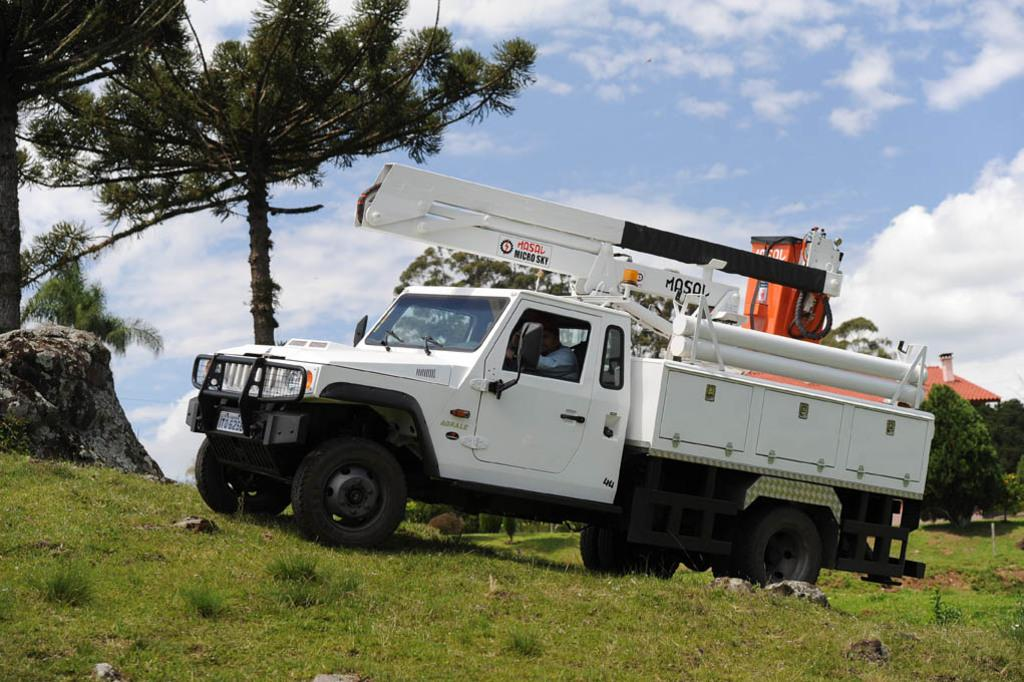What is happening in the image involving a person and a vehicle? There is a person inside a vehicle in the image. Can you describe the setting in which the vehicle is passing? The vehicle is passing on the grass. What other objects or structures can be seen in the image? There is a rock, a house, and trees in the image. What is visible in the background of the image? The sky is visible in the background of the image, and clouds are present in the sky. What is the income of the person driving the vehicle in the image? There is no information about the person's income in the image. How many friends are visible in the image? There are no friends visible in the image; it only shows a person inside a vehicle, a rock, a house, trees, and the sky. 